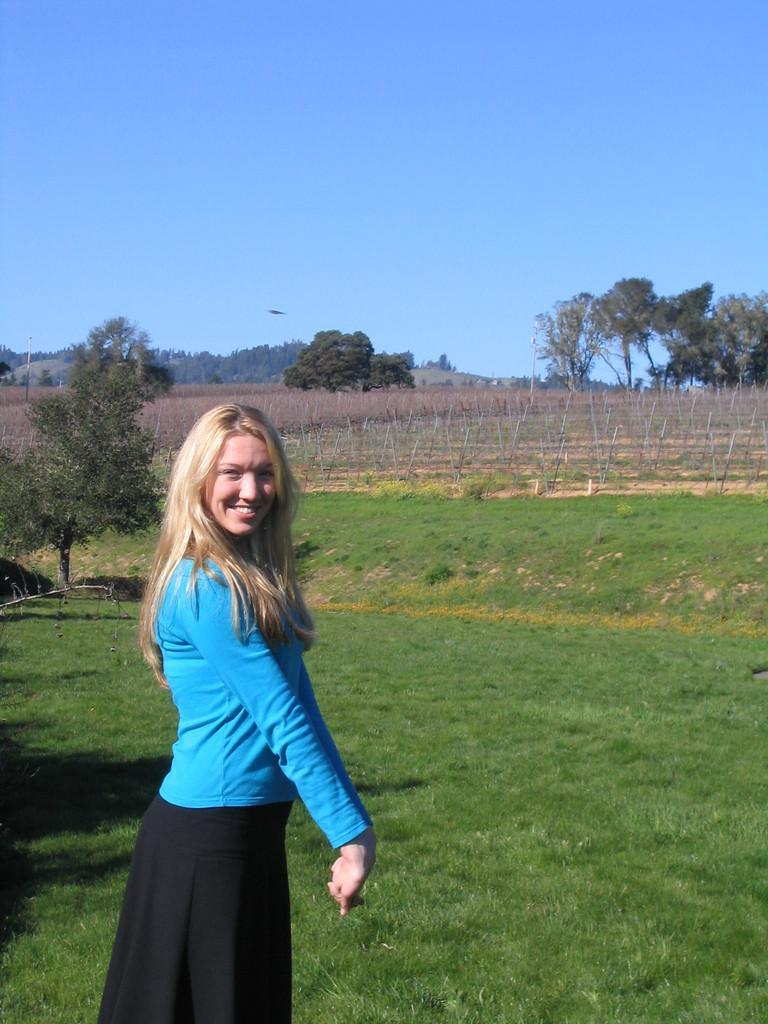Please provide a concise description of this image. In this image I can see a woman wearing blue and black colored dress is standing and smiling. I can see some grass on the ground, few poles, few trees and the sky in the background. 